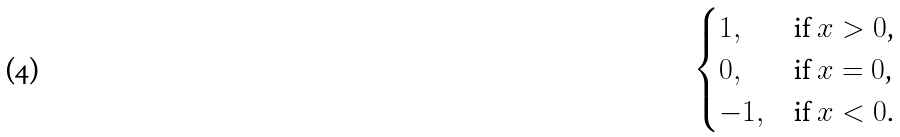<formula> <loc_0><loc_0><loc_500><loc_500>\begin{cases} 1 , & \text {if $x > 0$,} \\ 0 , & \text {if $x = 0$,} \\ - 1 , & \text {if $x < 0$.} \end{cases}</formula> 